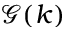Convert formula to latex. <formula><loc_0><loc_0><loc_500><loc_500>\mathcal { G } ( k )</formula> 